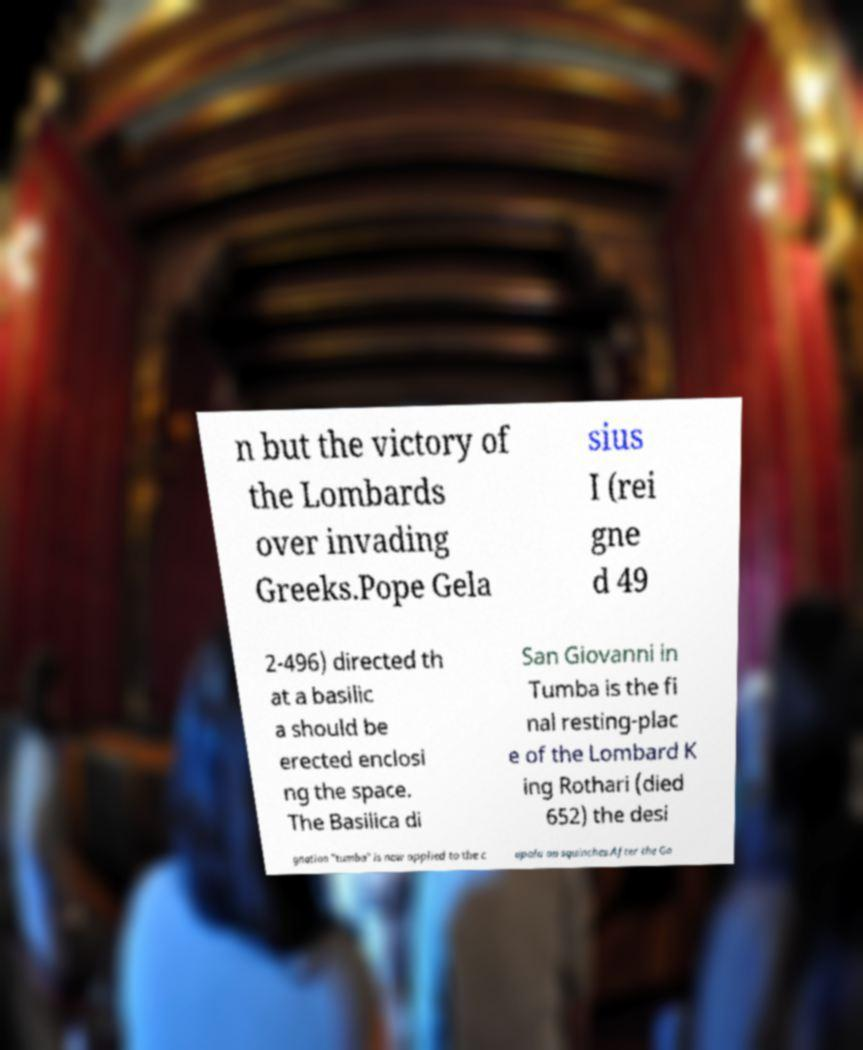Could you extract and type out the text from this image? n but the victory of the Lombards over invading Greeks.Pope Gela sius I (rei gne d 49 2-496) directed th at a basilic a should be erected enclosi ng the space. The Basilica di San Giovanni in Tumba is the fi nal resting-plac e of the Lombard K ing Rothari (died 652) the desi gnation "tumba" is now applied to the c upola on squinches.After the Go 